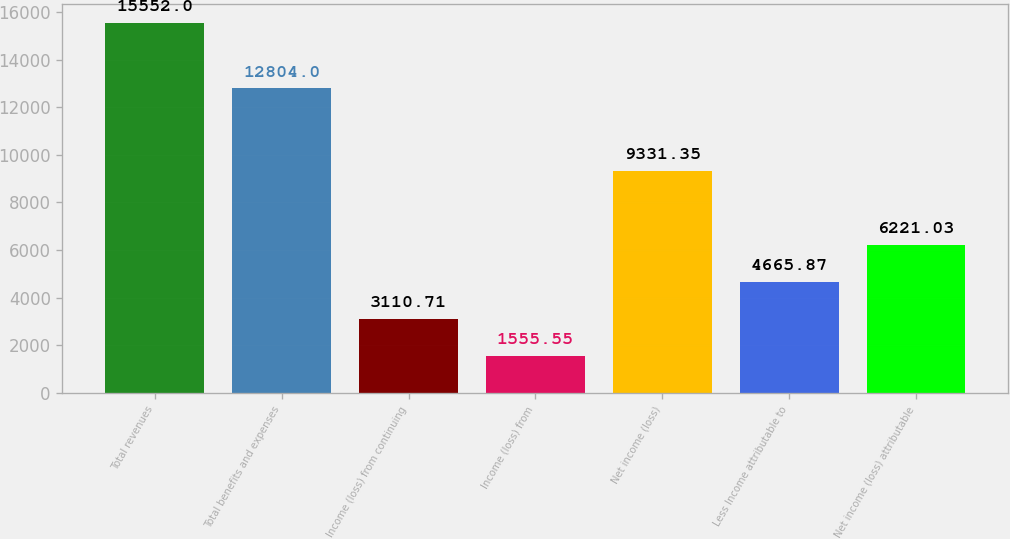Convert chart to OTSL. <chart><loc_0><loc_0><loc_500><loc_500><bar_chart><fcel>Total revenues<fcel>Total benefits and expenses<fcel>Income (loss) from continuing<fcel>Income (loss) from<fcel>Net income (loss)<fcel>Less Income attributable to<fcel>Net income (loss) attributable<nl><fcel>15552<fcel>12804<fcel>3110.71<fcel>1555.55<fcel>9331.35<fcel>4665.87<fcel>6221.03<nl></chart> 